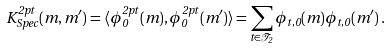Convert formula to latex. <formula><loc_0><loc_0><loc_500><loc_500>K _ { S p e c } ^ { 2 p t } ( m , m ^ { \prime } ) = \langle \phi _ { 0 } ^ { 2 p t } ( m ) , \phi _ { 0 } ^ { 2 p t } ( m ^ { \prime } ) \rangle = \sum _ { t \in \mathcal { T } _ { 2 } } \phi _ { t , 0 } ( m ) \phi _ { t , 0 } ( m ^ { \prime } ) \, .</formula> 